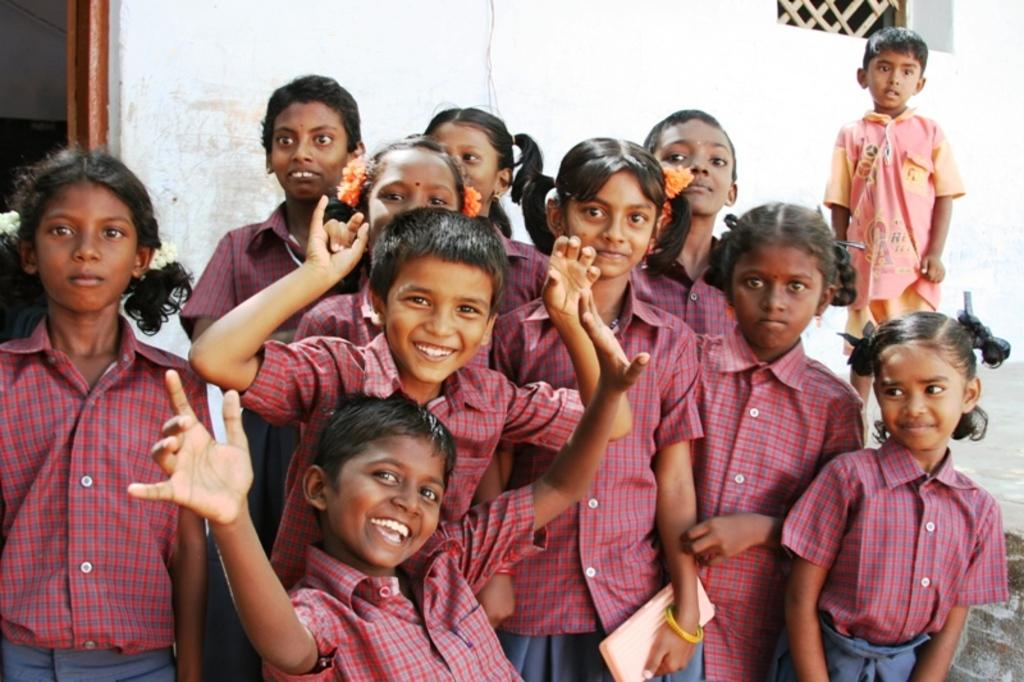Who is present in the image? There are children in the image. What are the children wearing? The children are wearing uniforms. What is the facial expression of the children? The children are smiling. What are the children doing in the image? The children are posing for the picture. What can be seen in the background of the image? There is a wall and a window in the background of the image. What type of ray is visible in the image? There is no ray present in the image. Can you see any fairies in the image? There are no fairies present in the image. 